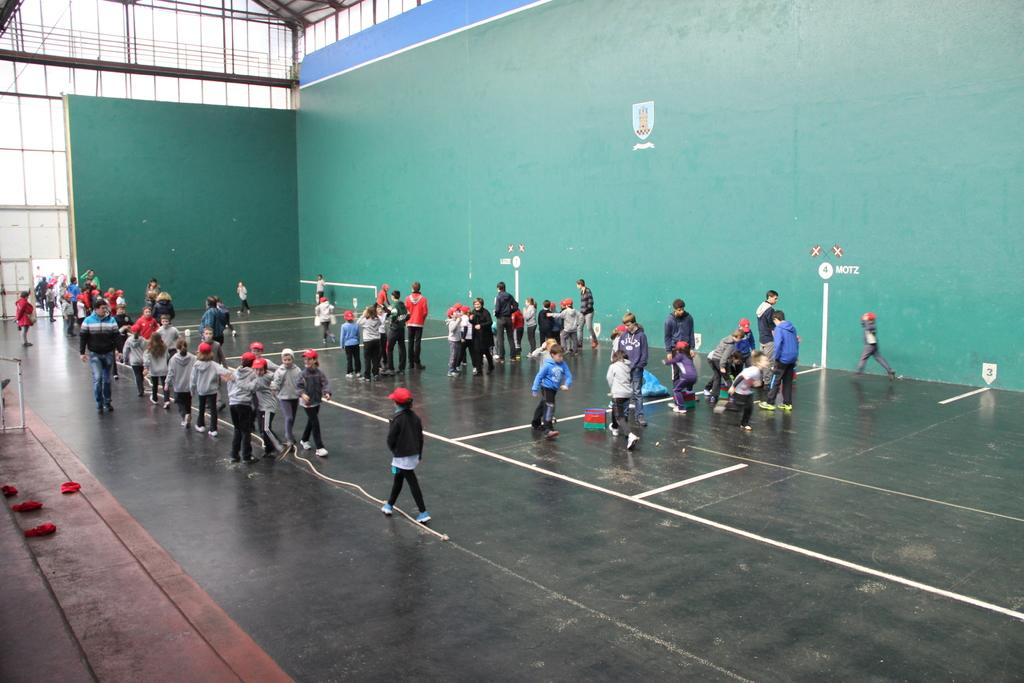What are the people in the image doing? There are groups of people standing on the floor, and some people are walking. What can be seen behind the people? There is a wall behind the people. What type of clock is hanging on the wall in the image? There is no clock visible in the image; only a wall is mentioned. What is the size of the flag in the image? There is no flag present in the image. 